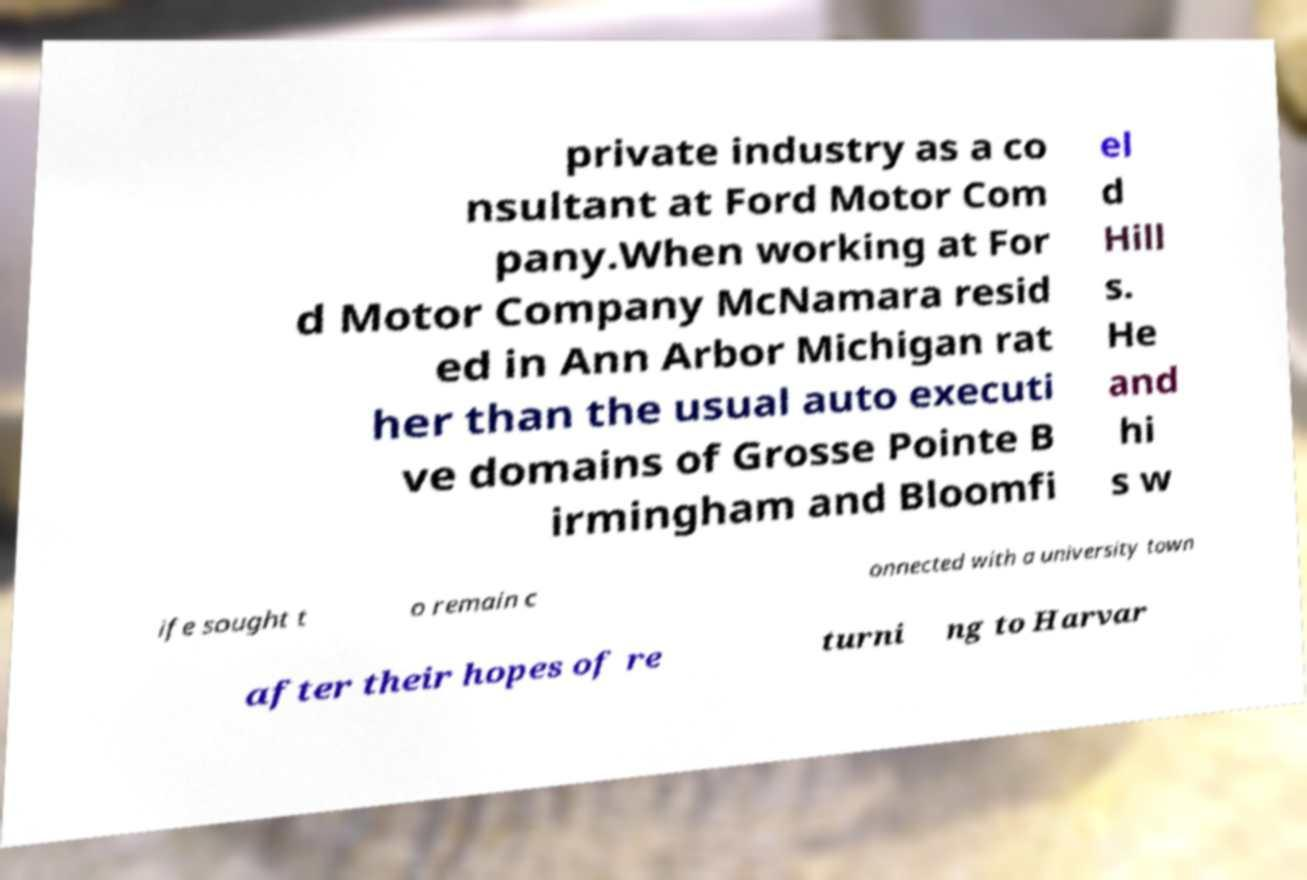Could you assist in decoding the text presented in this image and type it out clearly? private industry as a co nsultant at Ford Motor Com pany.When working at For d Motor Company McNamara resid ed in Ann Arbor Michigan rat her than the usual auto executi ve domains of Grosse Pointe B irmingham and Bloomfi el d Hill s. He and hi s w ife sought t o remain c onnected with a university town after their hopes of re turni ng to Harvar 